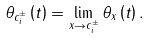<formula> <loc_0><loc_0><loc_500><loc_500>\theta _ { c _ { i } ^ { \pm } } \left ( t \right ) = \lim _ { x \rightarrow c _ { i } ^ { \pm } } \theta _ { x } \left ( t \right ) .</formula> 